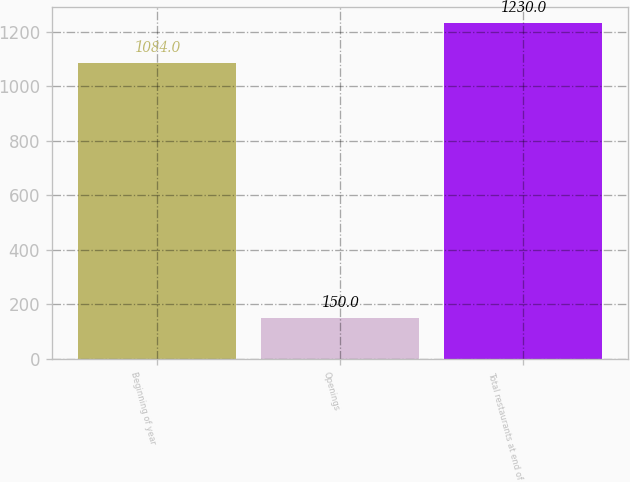Convert chart. <chart><loc_0><loc_0><loc_500><loc_500><bar_chart><fcel>Beginning of year<fcel>Openings<fcel>Total restaurants at end of<nl><fcel>1084<fcel>150<fcel>1230<nl></chart> 